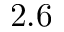Convert formula to latex. <formula><loc_0><loc_0><loc_500><loc_500>2 . 6</formula> 